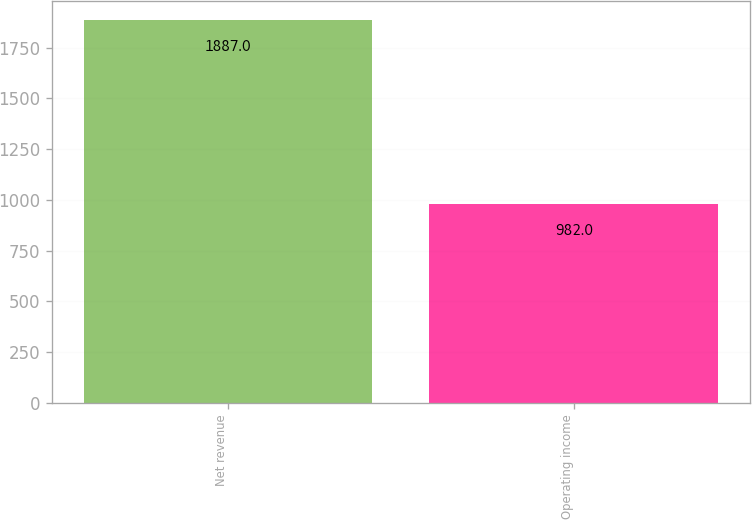<chart> <loc_0><loc_0><loc_500><loc_500><bar_chart><fcel>Net revenue<fcel>Operating income<nl><fcel>1887<fcel>982<nl></chart> 